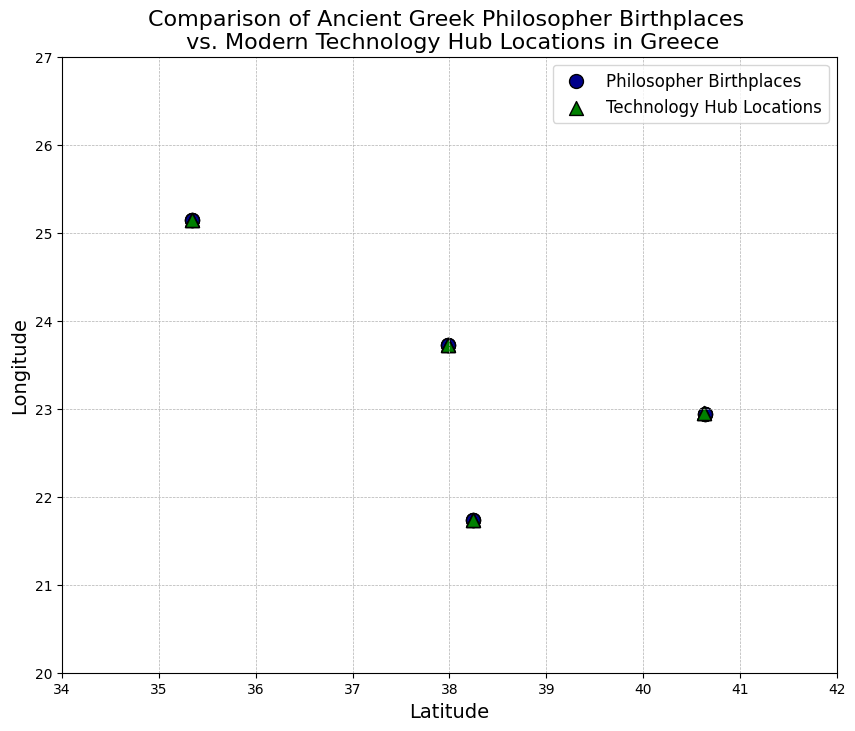What locations appear both as philosopher birthplaces and as modern technology hubs? Comparing the data points, Athens (37.9838, 23.7275) and Patras (38.2466, 21.7346) appear both as philosopher birthplaces and technology hubs.
Answer: Athens and Patras Which points on the map share the same longitude? By comparing the longitudes, Athens (23.7275) appears for both philosopher birthplaces and technology hubs.
Answer: Athens Which modern technology hub lies furthest east? By checking the longitudes, Heraklion (25.1442) lies furthest east.
Answer: Heraklion What is the average latitude of all philosopher birthplaces? Summing the latitudes (37.9838, 37.9838, 37.9838, 37.9838, 38.2466, 38.2466, 38.2466, 38.2466, 35.3387, 35.3387, 35.3387, 35.3387, 40.6413, 40.6413, 40.6413, 40.6413) and dividing by 16 gives (611.3216 / 16) = 38.2076.
Answer: 38.2076 Which locations appear to have philosophers grouped more closely in terms of latitude and longitude? Based on the scatter plot, Athens (37.9838, 23.7275) has closely grouped philosopher birthplaces.
Answer: Athens Which city has both a philosopher birthplace and a technology hub that are exactly at the same coordinate? By looking at the scatter plot, both Athens (37.9838, 23.7275) and Patras (38.2466, 21.7346) share exact coordinates for philosopher birthplaces and technology hubs.
Answer: Athens and Patras How many philosopher birthplaces are there within a latitude range of 1 degree from Heraklion? Heraklion's latitude is 35.3387. Considering +/- 1 degree (34.3387 to 36.3387), only Heraklion (35.3387) is located within this range.
Answer: 4 What are the northernmost and southernmost philosopher birthplaces? The northernmost birthplace is Thessaloniki (40.6413), and the southernmost is Heraklion (35.3387).
Answer: Thessaloniki and Heraklion 